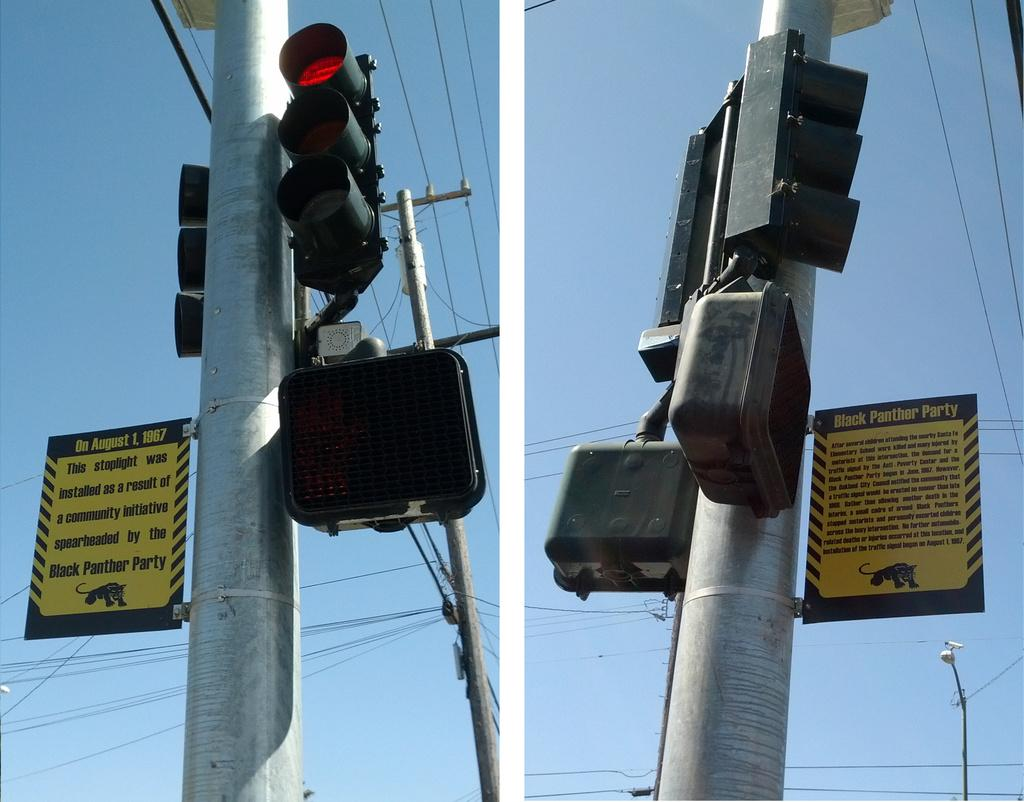<image>
Summarize the visual content of the image. Two sets of traffic lights with an attached sign saying they were installed by the Black Panthers. 